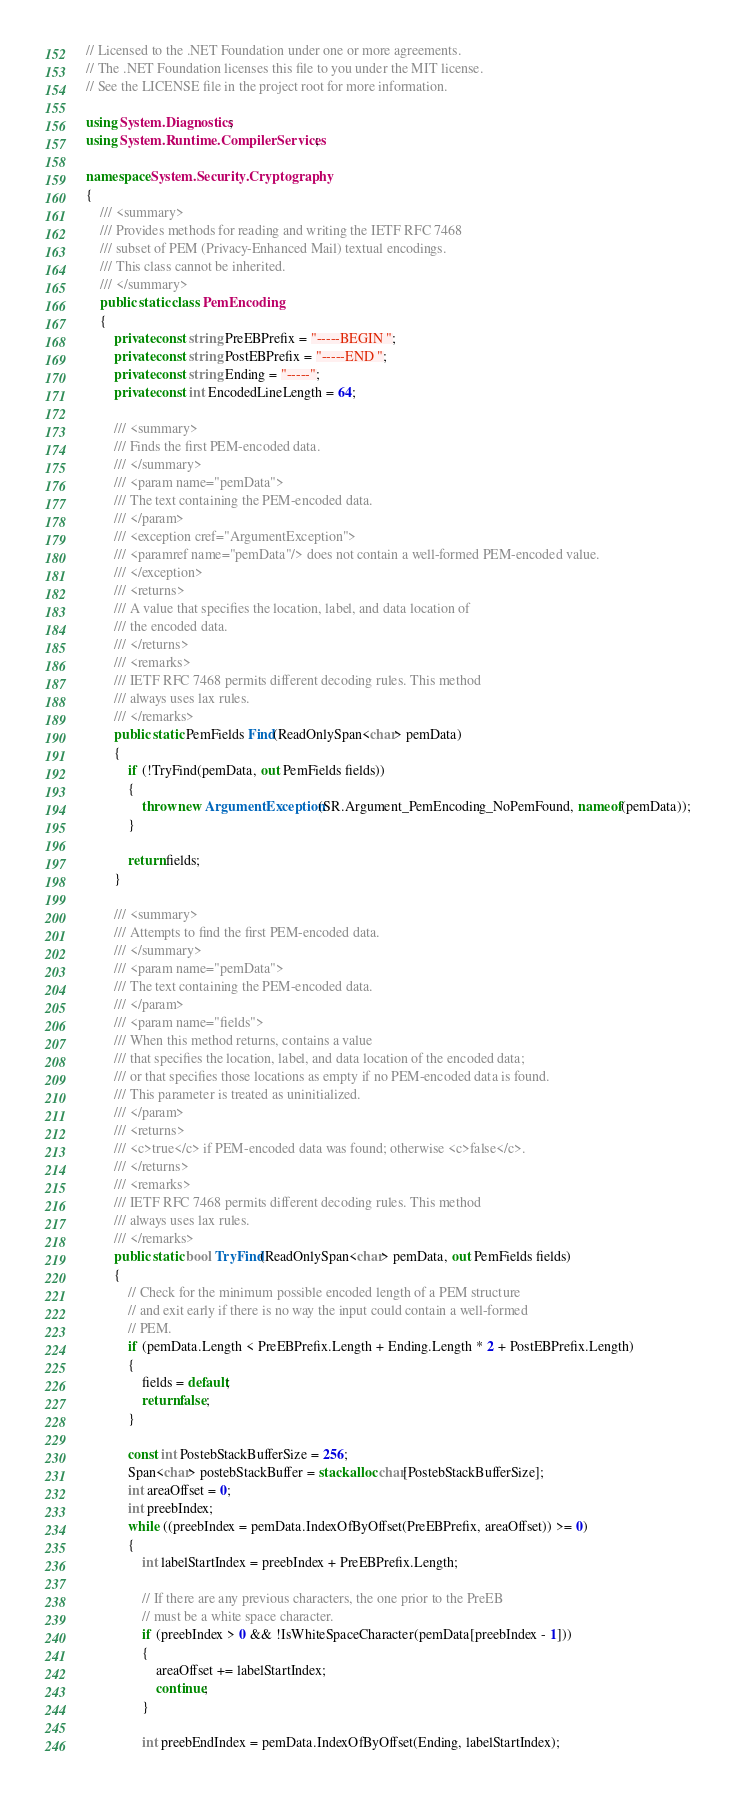<code> <loc_0><loc_0><loc_500><loc_500><_C#_>// Licensed to the .NET Foundation under one or more agreements.
// The .NET Foundation licenses this file to you under the MIT license.
// See the LICENSE file in the project root for more information.

using System.Diagnostics;
using System.Runtime.CompilerServices;

namespace System.Security.Cryptography
{
    /// <summary>
    /// Provides methods for reading and writing the IETF RFC 7468
    /// subset of PEM (Privacy-Enhanced Mail) textual encodings.
    /// This class cannot be inherited.
    /// </summary>
    public static class PemEncoding
    {
        private const string PreEBPrefix = "-----BEGIN ";
        private const string PostEBPrefix = "-----END ";
        private const string Ending = "-----";
        private const int EncodedLineLength = 64;

        /// <summary>
        /// Finds the first PEM-encoded data.
        /// </summary>
        /// <param name="pemData">
        /// The text containing the PEM-encoded data.
        /// </param>
        /// <exception cref="ArgumentException">
        /// <paramref name="pemData"/> does not contain a well-formed PEM-encoded value.
        /// </exception>
        /// <returns>
        /// A value that specifies the location, label, and data location of
        /// the encoded data.
        /// </returns>
        /// <remarks>
        /// IETF RFC 7468 permits different decoding rules. This method
        /// always uses lax rules.
        /// </remarks>
        public static PemFields Find(ReadOnlySpan<char> pemData)
        {
            if (!TryFind(pemData, out PemFields fields))
            {
                throw new ArgumentException(SR.Argument_PemEncoding_NoPemFound, nameof(pemData));
            }

            return fields;
        }

        /// <summary>
        /// Attempts to find the first PEM-encoded data.
        /// </summary>
        /// <param name="pemData">
        /// The text containing the PEM-encoded data.
        /// </param>
        /// <param name="fields">
        /// When this method returns, contains a value
        /// that specifies the location, label, and data location of the encoded data;
        /// or that specifies those locations as empty if no PEM-encoded data is found.
        /// This parameter is treated as uninitialized.
        /// </param>
        /// <returns>
        /// <c>true</c> if PEM-encoded data was found; otherwise <c>false</c>.
        /// </returns>
        /// <remarks>
        /// IETF RFC 7468 permits different decoding rules. This method
        /// always uses lax rules.
        /// </remarks>
        public static bool TryFind(ReadOnlySpan<char> pemData, out PemFields fields)
        {
            // Check for the minimum possible encoded length of a PEM structure
            // and exit early if there is no way the input could contain a well-formed
            // PEM.
            if (pemData.Length < PreEBPrefix.Length + Ending.Length * 2 + PostEBPrefix.Length)
            {
                fields = default;
                return false;
            }

            const int PostebStackBufferSize = 256;
            Span<char> postebStackBuffer = stackalloc char[PostebStackBufferSize];
            int areaOffset = 0;
            int preebIndex;
            while ((preebIndex = pemData.IndexOfByOffset(PreEBPrefix, areaOffset)) >= 0)
            {
                int labelStartIndex = preebIndex + PreEBPrefix.Length;

                // If there are any previous characters, the one prior to the PreEB
                // must be a white space character.
                if (preebIndex > 0 && !IsWhiteSpaceCharacter(pemData[preebIndex - 1]))
                {
                    areaOffset += labelStartIndex;
                    continue;
                }

                int preebEndIndex = pemData.IndexOfByOffset(Ending, labelStartIndex);
</code> 